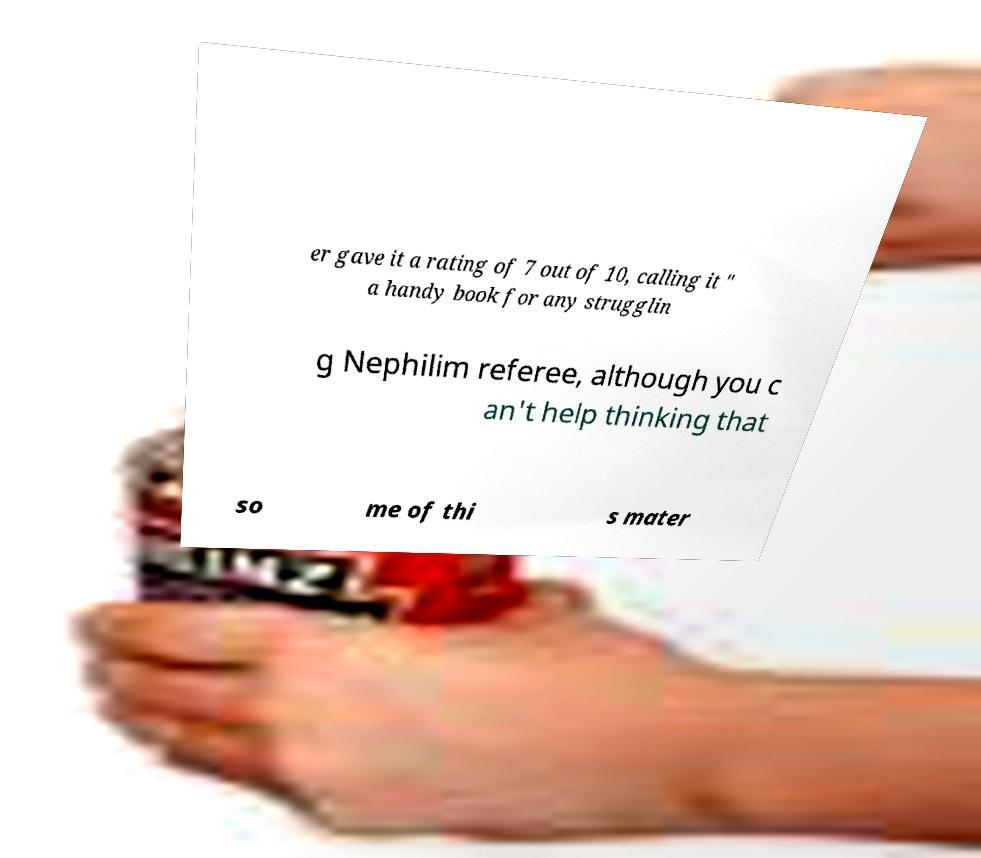For documentation purposes, I need the text within this image transcribed. Could you provide that? er gave it a rating of 7 out of 10, calling it " a handy book for any strugglin g Nephilim referee, although you c an't help thinking that so me of thi s mater 